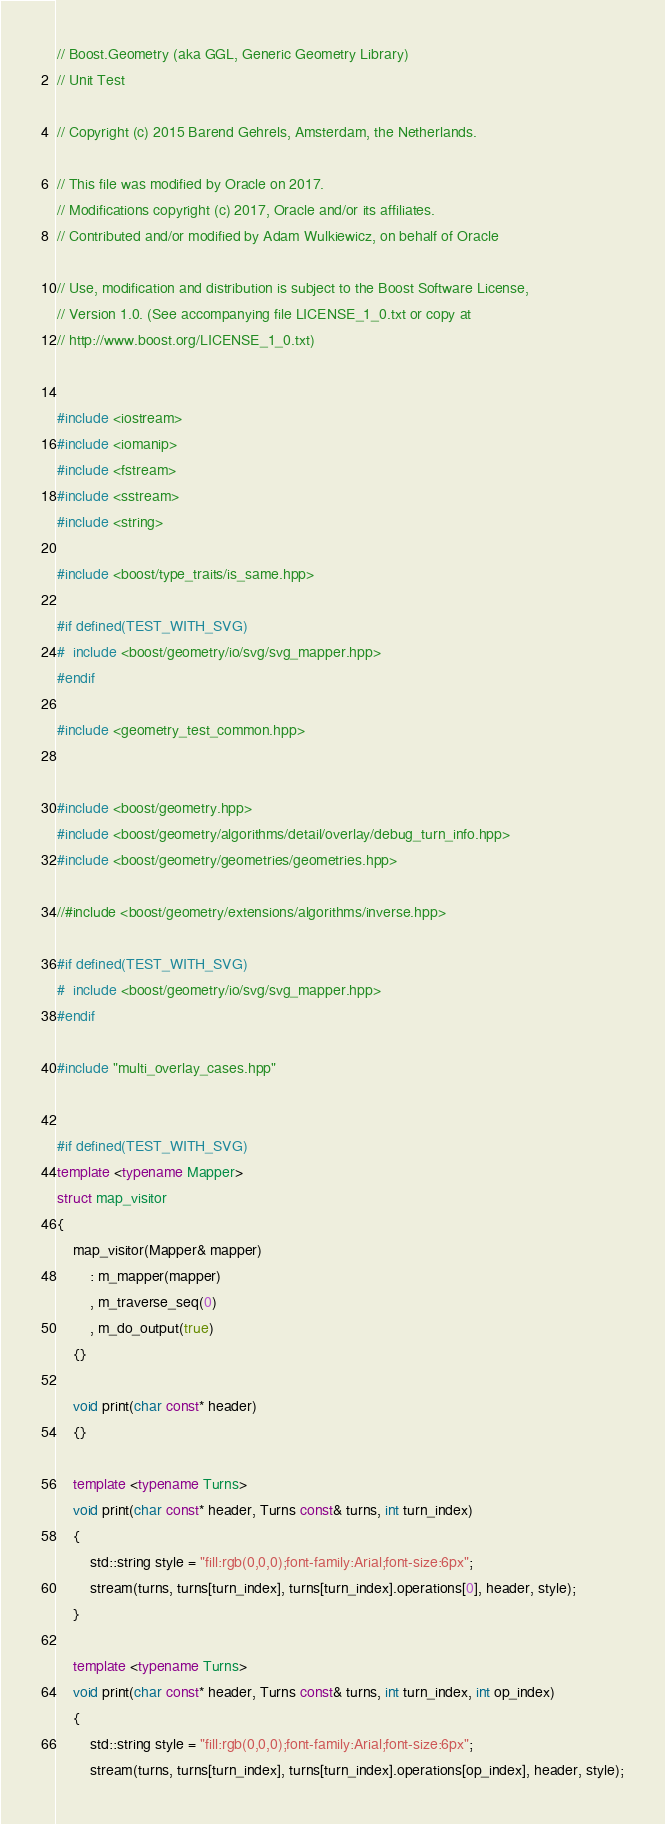Convert code to text. <code><loc_0><loc_0><loc_500><loc_500><_C++_>// Boost.Geometry (aka GGL, Generic Geometry Library)
// Unit Test

// Copyright (c) 2015 Barend Gehrels, Amsterdam, the Netherlands.

// This file was modified by Oracle on 2017.
// Modifications copyright (c) 2017, Oracle and/or its affiliates.
// Contributed and/or modified by Adam Wulkiewicz, on behalf of Oracle

// Use, modification and distribution is subject to the Boost Software License,
// Version 1.0. (See accompanying file LICENSE_1_0.txt or copy at
// http://www.boost.org/LICENSE_1_0.txt)


#include <iostream>
#include <iomanip>
#include <fstream>
#include <sstream>
#include <string>

#include <boost/type_traits/is_same.hpp>

#if defined(TEST_WITH_SVG)
#  include <boost/geometry/io/svg/svg_mapper.hpp>
#endif

#include <geometry_test_common.hpp>


#include <boost/geometry.hpp>
#include <boost/geometry/algorithms/detail/overlay/debug_turn_info.hpp>
#include <boost/geometry/geometries/geometries.hpp>

//#include <boost/geometry/extensions/algorithms/inverse.hpp>

#if defined(TEST_WITH_SVG)
#  include <boost/geometry/io/svg/svg_mapper.hpp>
#endif

#include "multi_overlay_cases.hpp"


#if defined(TEST_WITH_SVG)
template <typename Mapper>
struct map_visitor
{
    map_visitor(Mapper& mapper)
        : m_mapper(mapper)
        , m_traverse_seq(0)
        , m_do_output(true)
    {}

    void print(char const* header)
    {}

    template <typename Turns>
    void print(char const* header, Turns const& turns, int turn_index)
    {
        std::string style = "fill:rgb(0,0,0);font-family:Arial;font-size:6px";
        stream(turns, turns[turn_index], turns[turn_index].operations[0], header, style);
    }

    template <typename Turns>
    void print(char const* header, Turns const& turns, int turn_index, int op_index)
    {
        std::string style = "fill:rgb(0,0,0);font-family:Arial;font-size:6px";
        stream(turns, turns[turn_index], turns[turn_index].operations[op_index], header, style);</code> 